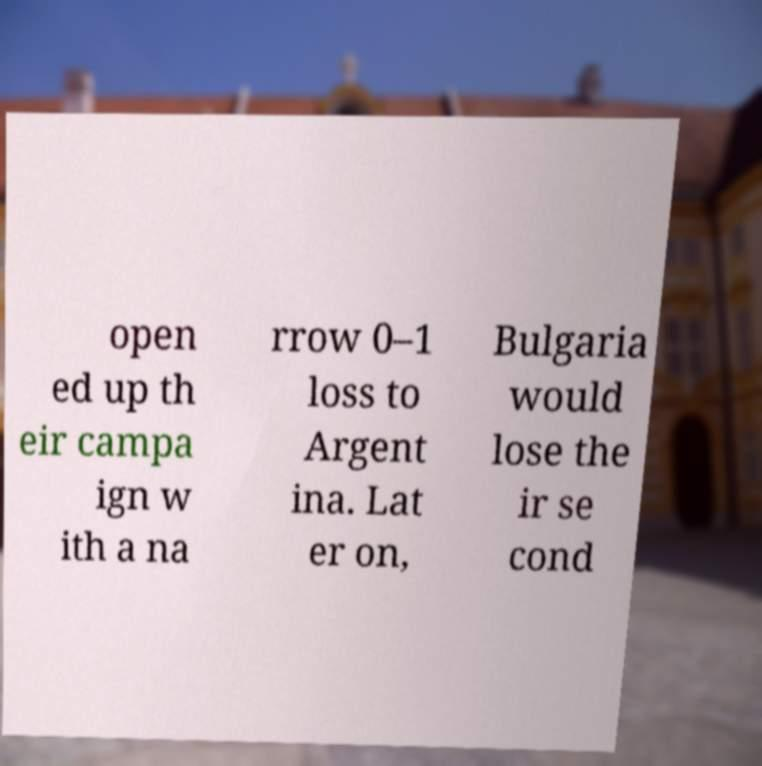Please read and relay the text visible in this image. What does it say? open ed up th eir campa ign w ith a na rrow 0–1 loss to Argent ina. Lat er on, Bulgaria would lose the ir se cond 